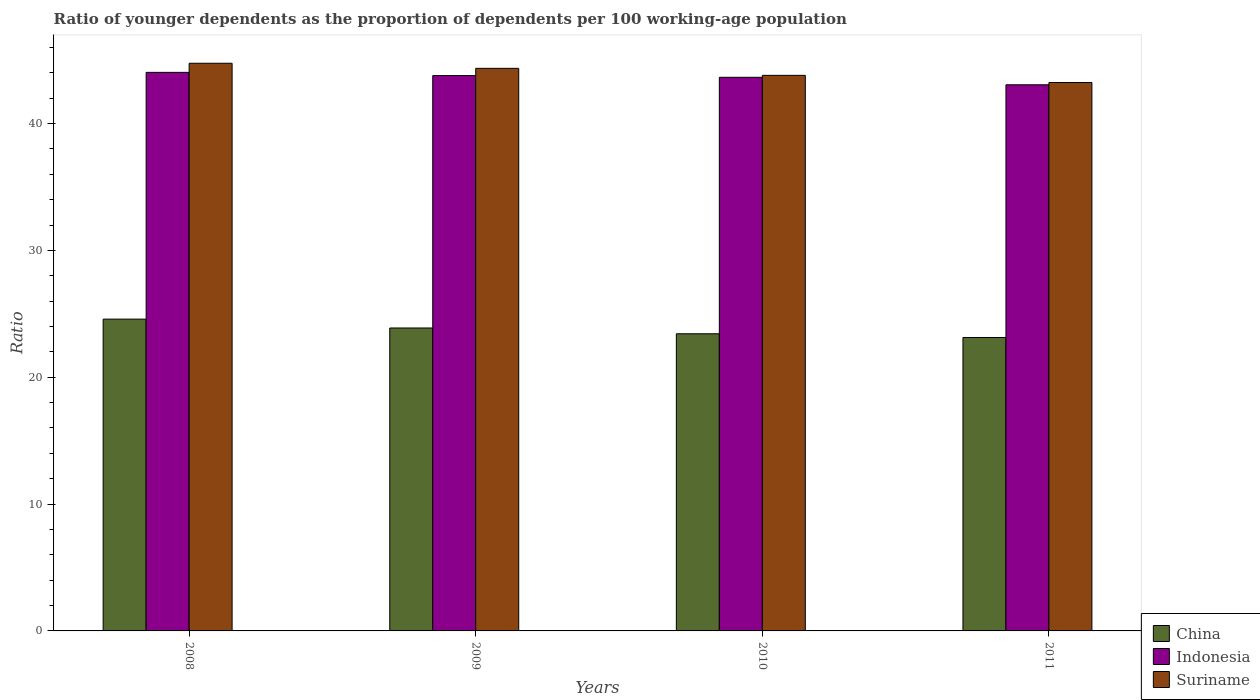How many bars are there on the 2nd tick from the left?
Make the answer very short. 3. How many bars are there on the 2nd tick from the right?
Offer a terse response. 3. What is the label of the 4th group of bars from the left?
Your answer should be compact. 2011. What is the age dependency ratio(young) in Indonesia in 2010?
Make the answer very short. 43.65. Across all years, what is the maximum age dependency ratio(young) in Indonesia?
Offer a terse response. 44.04. Across all years, what is the minimum age dependency ratio(young) in China?
Keep it short and to the point. 23.13. In which year was the age dependency ratio(young) in China maximum?
Give a very brief answer. 2008. What is the total age dependency ratio(young) in China in the graph?
Your answer should be very brief. 95.02. What is the difference between the age dependency ratio(young) in Suriname in 2008 and that in 2009?
Offer a terse response. 0.4. What is the difference between the age dependency ratio(young) in China in 2011 and the age dependency ratio(young) in Indonesia in 2009?
Your answer should be very brief. -20.65. What is the average age dependency ratio(young) in China per year?
Offer a very short reply. 23.76. In the year 2009, what is the difference between the age dependency ratio(young) in Suriname and age dependency ratio(young) in China?
Offer a terse response. 20.47. What is the ratio of the age dependency ratio(young) in China in 2008 to that in 2010?
Provide a succinct answer. 1.05. Is the age dependency ratio(young) in China in 2010 less than that in 2011?
Give a very brief answer. No. What is the difference between the highest and the second highest age dependency ratio(young) in China?
Make the answer very short. 0.7. What is the difference between the highest and the lowest age dependency ratio(young) in Indonesia?
Offer a terse response. 0.98. In how many years, is the age dependency ratio(young) in Suriname greater than the average age dependency ratio(young) in Suriname taken over all years?
Offer a very short reply. 2. Is the sum of the age dependency ratio(young) in Indonesia in 2009 and 2010 greater than the maximum age dependency ratio(young) in China across all years?
Keep it short and to the point. Yes. How many bars are there?
Keep it short and to the point. 12. Are all the bars in the graph horizontal?
Give a very brief answer. No. What is the difference between two consecutive major ticks on the Y-axis?
Provide a short and direct response. 10. Are the values on the major ticks of Y-axis written in scientific E-notation?
Offer a terse response. No. Where does the legend appear in the graph?
Your answer should be very brief. Bottom right. What is the title of the graph?
Offer a terse response. Ratio of younger dependents as the proportion of dependents per 100 working-age population. Does "Virgin Islands" appear as one of the legend labels in the graph?
Ensure brevity in your answer.  No. What is the label or title of the Y-axis?
Offer a terse response. Ratio. What is the Ratio in China in 2008?
Your answer should be compact. 24.58. What is the Ratio of Indonesia in 2008?
Your response must be concise. 44.04. What is the Ratio in Suriname in 2008?
Provide a succinct answer. 44.75. What is the Ratio of China in 2009?
Your answer should be compact. 23.88. What is the Ratio of Indonesia in 2009?
Your answer should be compact. 43.78. What is the Ratio in Suriname in 2009?
Provide a short and direct response. 44.35. What is the Ratio of China in 2010?
Your response must be concise. 23.43. What is the Ratio in Indonesia in 2010?
Offer a very short reply. 43.65. What is the Ratio of Suriname in 2010?
Provide a short and direct response. 43.8. What is the Ratio of China in 2011?
Your answer should be compact. 23.13. What is the Ratio of Indonesia in 2011?
Provide a short and direct response. 43.06. What is the Ratio in Suriname in 2011?
Your answer should be compact. 43.23. Across all years, what is the maximum Ratio of China?
Your answer should be very brief. 24.58. Across all years, what is the maximum Ratio in Indonesia?
Provide a succinct answer. 44.04. Across all years, what is the maximum Ratio in Suriname?
Offer a very short reply. 44.75. Across all years, what is the minimum Ratio of China?
Give a very brief answer. 23.13. Across all years, what is the minimum Ratio in Indonesia?
Make the answer very short. 43.06. Across all years, what is the minimum Ratio of Suriname?
Keep it short and to the point. 43.23. What is the total Ratio of China in the graph?
Give a very brief answer. 95.02. What is the total Ratio in Indonesia in the graph?
Provide a short and direct response. 174.52. What is the total Ratio in Suriname in the graph?
Offer a very short reply. 176.14. What is the difference between the Ratio in China in 2008 and that in 2009?
Your answer should be compact. 0.7. What is the difference between the Ratio of Indonesia in 2008 and that in 2009?
Your answer should be compact. 0.25. What is the difference between the Ratio of Suriname in 2008 and that in 2009?
Offer a very short reply. 0.4. What is the difference between the Ratio in China in 2008 and that in 2010?
Offer a terse response. 1.15. What is the difference between the Ratio in Indonesia in 2008 and that in 2010?
Offer a very short reply. 0.39. What is the difference between the Ratio in Suriname in 2008 and that in 2010?
Provide a short and direct response. 0.95. What is the difference between the Ratio in China in 2008 and that in 2011?
Your answer should be compact. 1.45. What is the difference between the Ratio in Indonesia in 2008 and that in 2011?
Make the answer very short. 0.98. What is the difference between the Ratio in Suriname in 2008 and that in 2011?
Give a very brief answer. 1.52. What is the difference between the Ratio of China in 2009 and that in 2010?
Ensure brevity in your answer.  0.46. What is the difference between the Ratio of Indonesia in 2009 and that in 2010?
Provide a short and direct response. 0.14. What is the difference between the Ratio of Suriname in 2009 and that in 2010?
Offer a very short reply. 0.55. What is the difference between the Ratio of China in 2009 and that in 2011?
Keep it short and to the point. 0.75. What is the difference between the Ratio of Indonesia in 2009 and that in 2011?
Your response must be concise. 0.73. What is the difference between the Ratio in Suriname in 2009 and that in 2011?
Give a very brief answer. 1.12. What is the difference between the Ratio in China in 2010 and that in 2011?
Make the answer very short. 0.29. What is the difference between the Ratio in Indonesia in 2010 and that in 2011?
Provide a short and direct response. 0.59. What is the difference between the Ratio in Suriname in 2010 and that in 2011?
Make the answer very short. 0.57. What is the difference between the Ratio in China in 2008 and the Ratio in Indonesia in 2009?
Ensure brevity in your answer.  -19.2. What is the difference between the Ratio in China in 2008 and the Ratio in Suriname in 2009?
Ensure brevity in your answer.  -19.77. What is the difference between the Ratio of Indonesia in 2008 and the Ratio of Suriname in 2009?
Provide a succinct answer. -0.32. What is the difference between the Ratio of China in 2008 and the Ratio of Indonesia in 2010?
Your answer should be compact. -19.07. What is the difference between the Ratio in China in 2008 and the Ratio in Suriname in 2010?
Make the answer very short. -19.22. What is the difference between the Ratio in Indonesia in 2008 and the Ratio in Suriname in 2010?
Provide a short and direct response. 0.23. What is the difference between the Ratio of China in 2008 and the Ratio of Indonesia in 2011?
Your answer should be very brief. -18.48. What is the difference between the Ratio of China in 2008 and the Ratio of Suriname in 2011?
Your response must be concise. -18.65. What is the difference between the Ratio in Indonesia in 2008 and the Ratio in Suriname in 2011?
Your answer should be very brief. 0.8. What is the difference between the Ratio in China in 2009 and the Ratio in Indonesia in 2010?
Provide a short and direct response. -19.76. What is the difference between the Ratio in China in 2009 and the Ratio in Suriname in 2010?
Your response must be concise. -19.92. What is the difference between the Ratio in Indonesia in 2009 and the Ratio in Suriname in 2010?
Provide a succinct answer. -0.02. What is the difference between the Ratio in China in 2009 and the Ratio in Indonesia in 2011?
Make the answer very short. -19.17. What is the difference between the Ratio in China in 2009 and the Ratio in Suriname in 2011?
Keep it short and to the point. -19.35. What is the difference between the Ratio in Indonesia in 2009 and the Ratio in Suriname in 2011?
Keep it short and to the point. 0.55. What is the difference between the Ratio of China in 2010 and the Ratio of Indonesia in 2011?
Your answer should be very brief. -19.63. What is the difference between the Ratio in China in 2010 and the Ratio in Suriname in 2011?
Ensure brevity in your answer.  -19.81. What is the difference between the Ratio of Indonesia in 2010 and the Ratio of Suriname in 2011?
Your answer should be compact. 0.41. What is the average Ratio in China per year?
Your response must be concise. 23.76. What is the average Ratio of Indonesia per year?
Give a very brief answer. 43.63. What is the average Ratio of Suriname per year?
Your response must be concise. 44.04. In the year 2008, what is the difference between the Ratio of China and Ratio of Indonesia?
Ensure brevity in your answer.  -19.46. In the year 2008, what is the difference between the Ratio of China and Ratio of Suriname?
Offer a terse response. -20.17. In the year 2008, what is the difference between the Ratio in Indonesia and Ratio in Suriname?
Your answer should be very brief. -0.72. In the year 2009, what is the difference between the Ratio in China and Ratio in Indonesia?
Make the answer very short. -19.9. In the year 2009, what is the difference between the Ratio in China and Ratio in Suriname?
Provide a short and direct response. -20.47. In the year 2009, what is the difference between the Ratio in Indonesia and Ratio in Suriname?
Make the answer very short. -0.57. In the year 2010, what is the difference between the Ratio in China and Ratio in Indonesia?
Offer a terse response. -20.22. In the year 2010, what is the difference between the Ratio in China and Ratio in Suriname?
Offer a terse response. -20.37. In the year 2010, what is the difference between the Ratio in Indonesia and Ratio in Suriname?
Make the answer very short. -0.15. In the year 2011, what is the difference between the Ratio of China and Ratio of Indonesia?
Your answer should be very brief. -19.92. In the year 2011, what is the difference between the Ratio of China and Ratio of Suriname?
Keep it short and to the point. -20.1. In the year 2011, what is the difference between the Ratio of Indonesia and Ratio of Suriname?
Keep it short and to the point. -0.18. What is the ratio of the Ratio in China in 2008 to that in 2009?
Make the answer very short. 1.03. What is the ratio of the Ratio in Indonesia in 2008 to that in 2009?
Your response must be concise. 1.01. What is the ratio of the Ratio in Suriname in 2008 to that in 2009?
Your answer should be very brief. 1.01. What is the ratio of the Ratio in China in 2008 to that in 2010?
Provide a succinct answer. 1.05. What is the ratio of the Ratio in Indonesia in 2008 to that in 2010?
Provide a succinct answer. 1.01. What is the ratio of the Ratio of Suriname in 2008 to that in 2010?
Your answer should be compact. 1.02. What is the ratio of the Ratio of China in 2008 to that in 2011?
Your answer should be compact. 1.06. What is the ratio of the Ratio in Indonesia in 2008 to that in 2011?
Keep it short and to the point. 1.02. What is the ratio of the Ratio in Suriname in 2008 to that in 2011?
Your response must be concise. 1.04. What is the ratio of the Ratio in China in 2009 to that in 2010?
Keep it short and to the point. 1.02. What is the ratio of the Ratio in Suriname in 2009 to that in 2010?
Ensure brevity in your answer.  1.01. What is the ratio of the Ratio in China in 2009 to that in 2011?
Ensure brevity in your answer.  1.03. What is the ratio of the Ratio of Indonesia in 2009 to that in 2011?
Give a very brief answer. 1.02. What is the ratio of the Ratio of Suriname in 2009 to that in 2011?
Offer a terse response. 1.03. What is the ratio of the Ratio of China in 2010 to that in 2011?
Provide a short and direct response. 1.01. What is the ratio of the Ratio in Indonesia in 2010 to that in 2011?
Your answer should be compact. 1.01. What is the ratio of the Ratio of Suriname in 2010 to that in 2011?
Provide a short and direct response. 1.01. What is the difference between the highest and the second highest Ratio of China?
Make the answer very short. 0.7. What is the difference between the highest and the second highest Ratio of Indonesia?
Provide a short and direct response. 0.25. What is the difference between the highest and the second highest Ratio in Suriname?
Ensure brevity in your answer.  0.4. What is the difference between the highest and the lowest Ratio of China?
Give a very brief answer. 1.45. What is the difference between the highest and the lowest Ratio in Indonesia?
Your answer should be very brief. 0.98. What is the difference between the highest and the lowest Ratio in Suriname?
Provide a short and direct response. 1.52. 